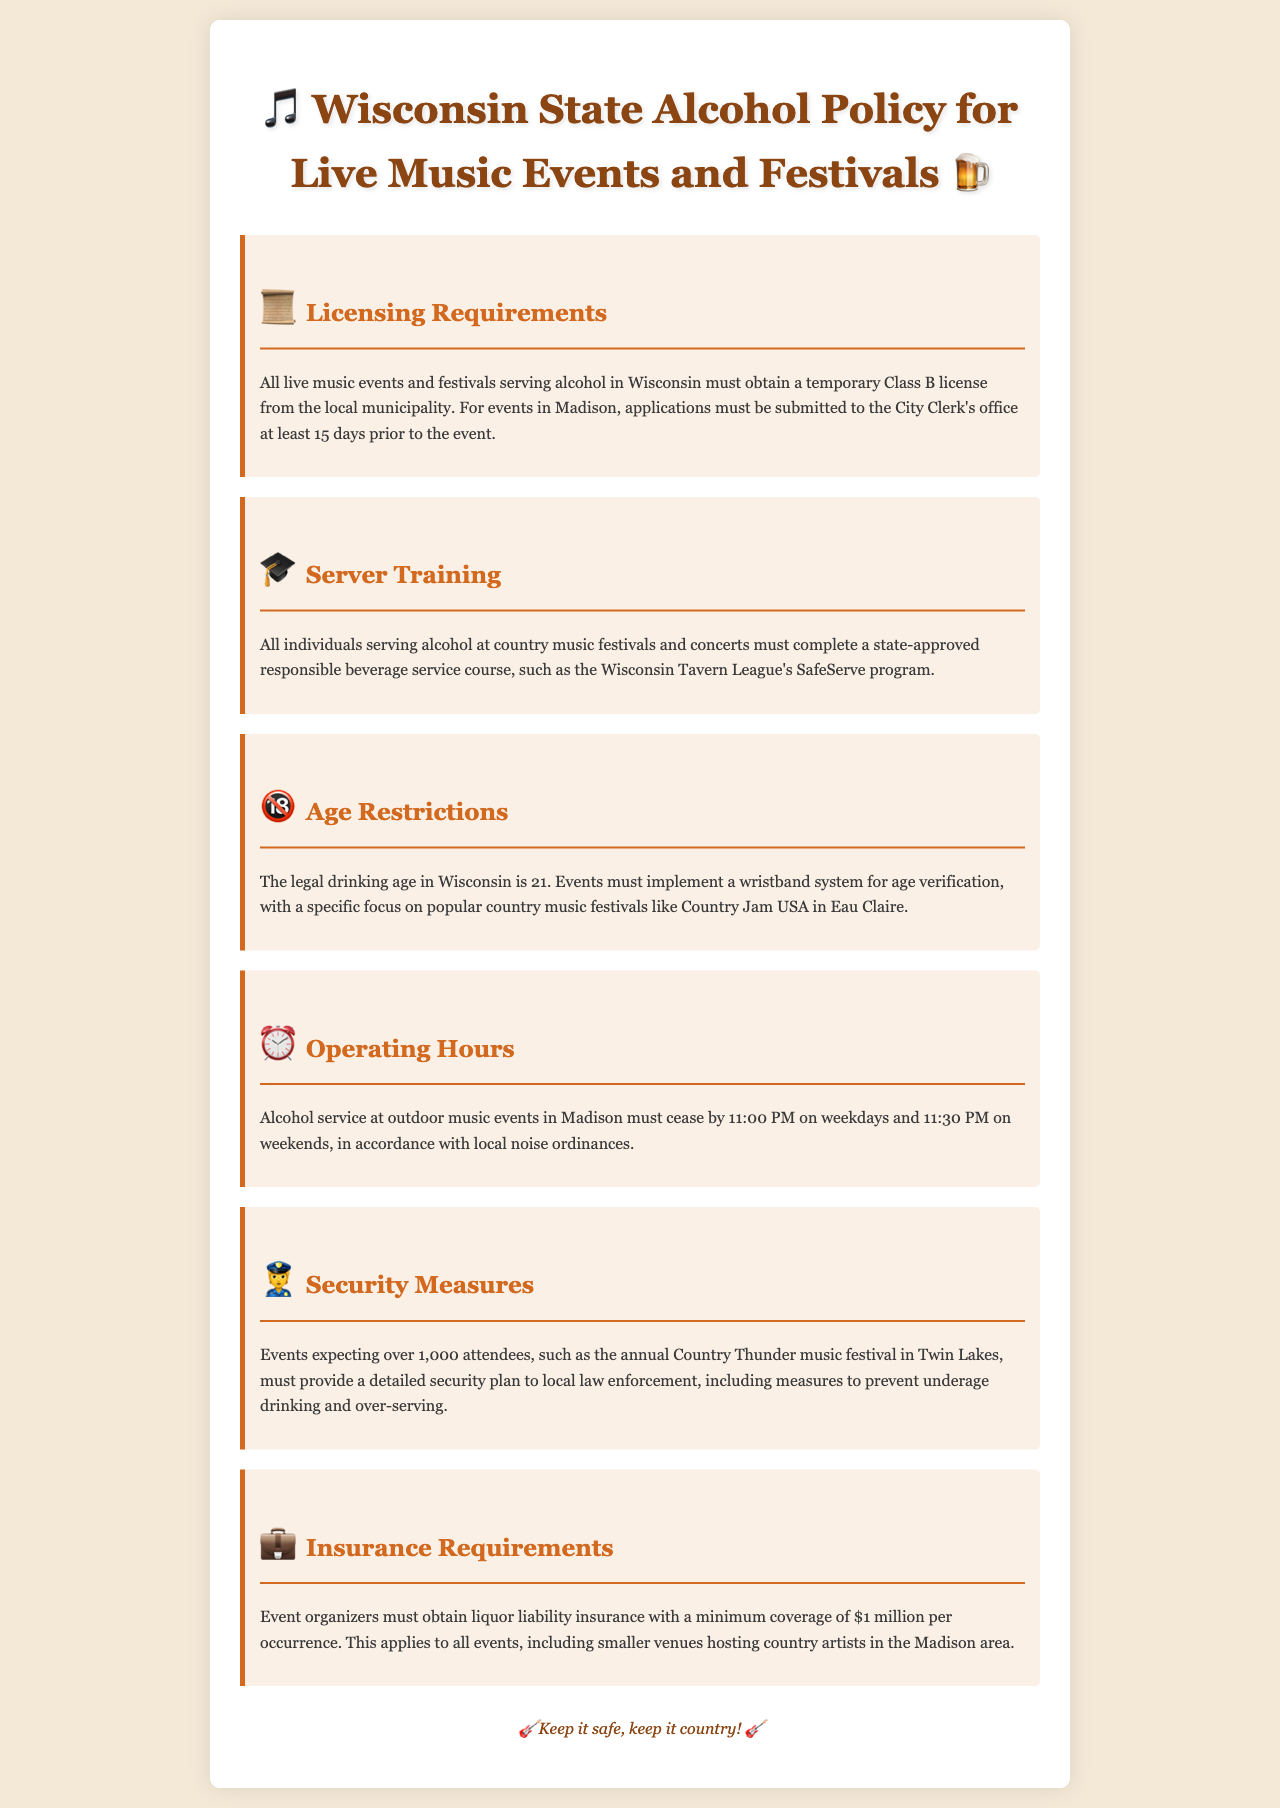What license is required for live music events serving alcohol? The document states that a temporary Class B license is required from the local municipality.
Answer: temporary Class B license How many days prior to the event must applications be submitted in Madison? The document specifies that applications must be submitted at least 15 days prior to the event.
Answer: 15 days What training program must servers complete? According to the document, individuals serving alcohol must complete a state-approved responsible beverage service course.
Answer: SafeServe program What time must outdoor alcohol service cease on weekends? The document indicates that alcohol service must cease by 11:30 PM on weekends.
Answer: 11:30 PM What is the minimum insurance coverage required for events? The document mentions that event organizers must obtain liquor liability insurance with a minimum coverage of $1 million per occurrence.
Answer: $1 million How is age verification implemented at events? The document specifies that a wristband system for age verification must be implemented.
Answer: wristband system What size of event requires a detailed security plan? The document states that events expecting over 1,000 attendees must provide a detailed security plan.
Answer: over 1,000 attendees What local event is mentioned as an example requiring a security plan? The document refers to the annual Country Thunder music festival in Twin Lakes as an example.
Answer: Country Thunder What is the legal drinking age in Wisconsin? The document clearly states that the legal drinking age in Wisconsin is 21.
Answer: 21 